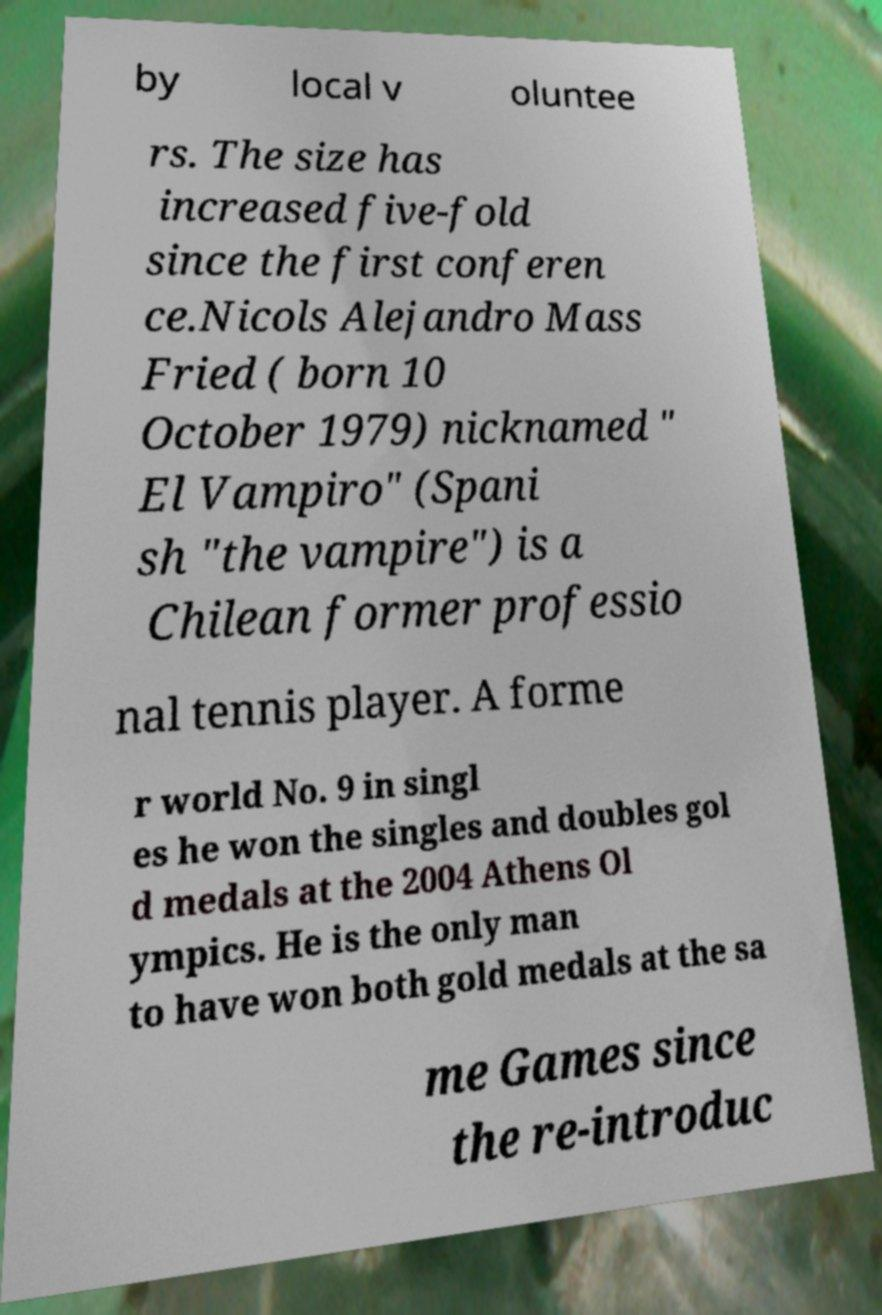I need the written content from this picture converted into text. Can you do that? by local v oluntee rs. The size has increased five-fold since the first conferen ce.Nicols Alejandro Mass Fried ( born 10 October 1979) nicknamed " El Vampiro" (Spani sh "the vampire") is a Chilean former professio nal tennis player. A forme r world No. 9 in singl es he won the singles and doubles gol d medals at the 2004 Athens Ol ympics. He is the only man to have won both gold medals at the sa me Games since the re-introduc 